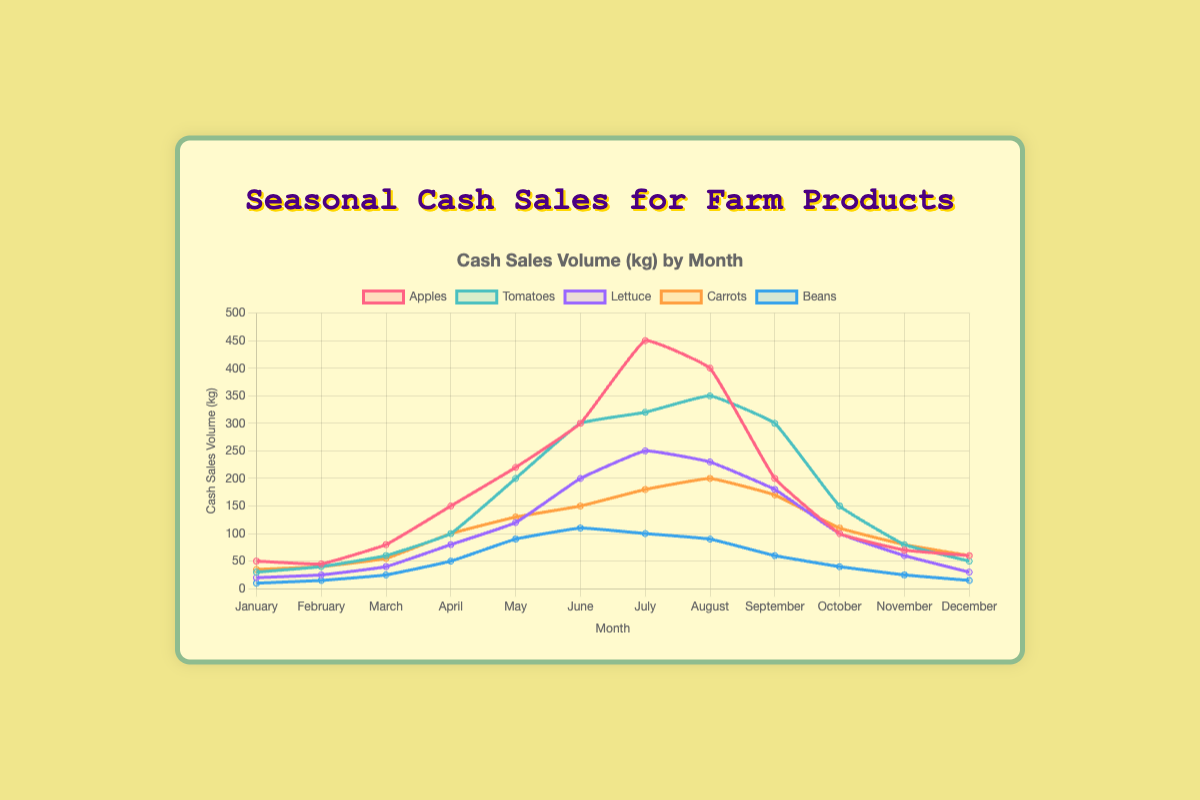How does the cash sales volume of Apples in peak month compare to that of Tomatoes in the same month? The peak month for Apples is July with 450 kg, and for Tomatoes, the same month's sales volume is 320 kg. Comparing both, Apples have a higher cash sales volume.
Answer: Apples have higher sales In which month do Beans have the lowest cash sales volume? By observing the line for Beans, the lowest sales volume is in January with 10 kg.
Answer: January Which product has the highest cash sales volume in June? In June, the line for Apples is the highest among all products. The sales volume for Apples in June is 300 kg, higher than Tomatoes (300 kg), Lettuce (200 kg), Carrots (150 kg), and Beans (110 kg).
Answer: Apples What is the total cash sales volume of Lettuce in the first quarter of the year? Adding the sales volumes of Lettuce for January (20 kg), February (25 kg), and March (40 kg): 20 + 25 + 40 = 85 kg.
Answer: 85 kg Calculate the average cash sales volume for Carrots from January to June. Adding the sales of Carrots from January to June: 35 (Jan) + 40 (Feb) + 55 (Mar) + 100 (Apr) + 130 (May) + 150 (Jun) = 510 kg. The average is 510 / 6 = 85 kg.
Answer: 85 kg Which months have the highest and lowest fluctuations in cash sales volume for Tomatoes? The highest fluctuation is from August to September, decreasing from 350 kg to 300 kg, and the lowest fluctuation is from September to October, decreasing from 300 kg to 150 kg.
Answer: August-September, September-October By how much does the cash sales volume of Lettuce increase from March to April? The sales of Lettuce in March are 40 kg and in April are 80 kg. The difference is 80 - 40 = 40 kg.
Answer: 40 kg If all products' sales were combined, what would the total cash sales volume be in December? Adding all products' sales in December: 60 (Apples) + 50 (Tomatoes) + 30 (Lettuce) + 60 (Carrots) + 15 (Beans) = 215 kg.
Answer: 215 kg 